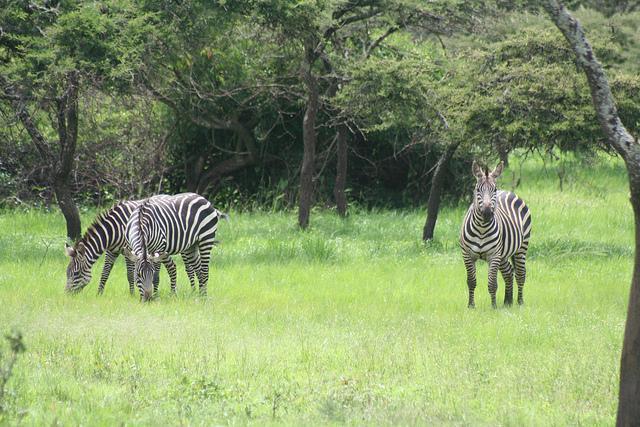How many zebras are there?
Give a very brief answer. 3. 